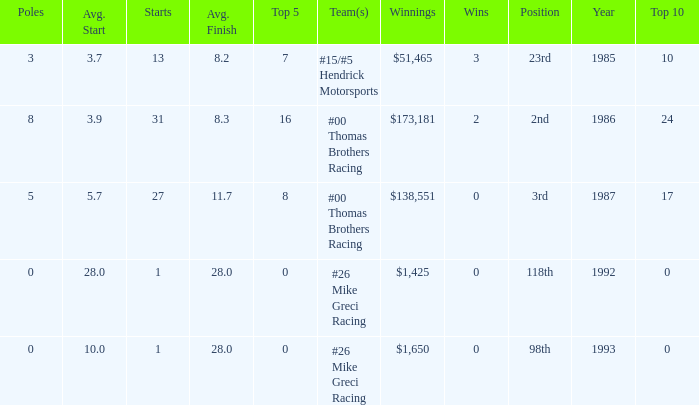What team was Bodine in when he had an average finish of 8.3? #00 Thomas Brothers Racing. 